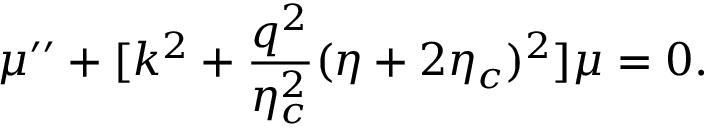Convert formula to latex. <formula><loc_0><loc_0><loc_500><loc_500>\mu ^ { \prime \prime } + [ k ^ { 2 } + \frac { q ^ { 2 } } { \eta _ { c } ^ { 2 } } ( \eta + 2 \eta _ { c } ) ^ { 2 } ] \mu = 0 .</formula> 